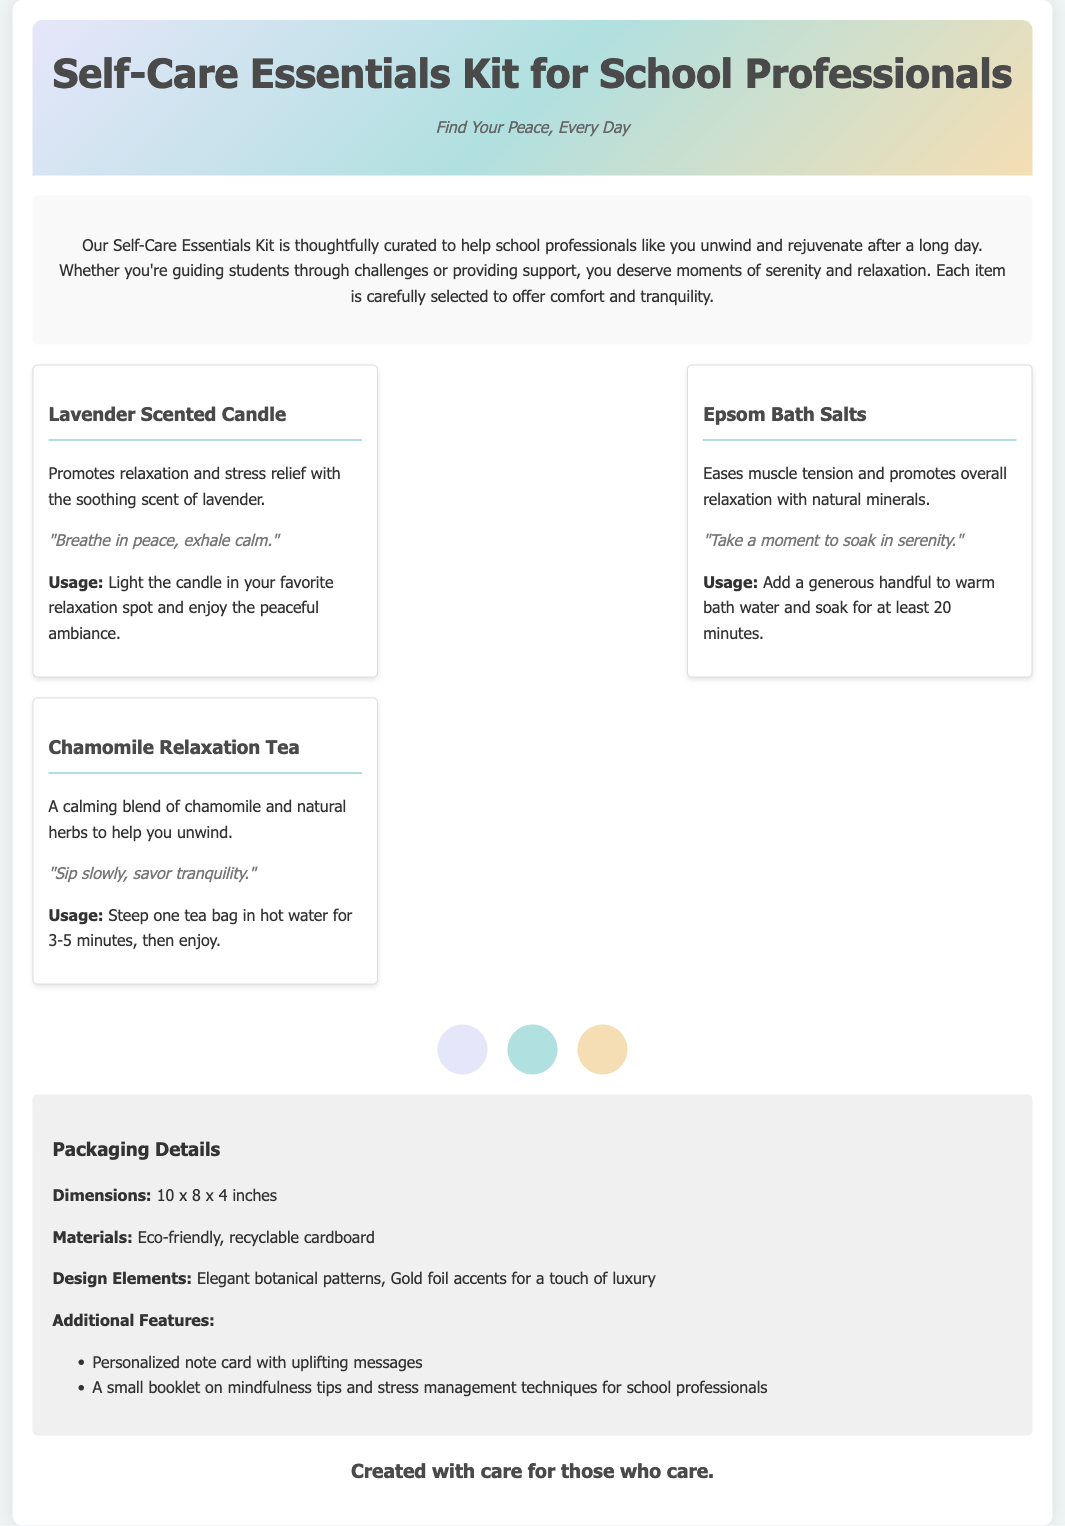what is included in the self-care essentials kit? The kit includes lavender scented candle, Epsom bath salts, and chamomile relaxation tea.
Answer: lavender scented candle, Epsom bath salts, chamomile relaxation tea what is the packaging material? The document states the packaging materials are eco-friendly and recyclable cardboard.
Answer: eco-friendly, recyclable cardboard what are the dimensions of the packaging? The dimensions of the packaging are specified within the document.
Answer: 10 x 8 x 4 inches what is the color scheme of the kit? The document mentions three colors in the color scheme: lavender, teal, and beige.
Answer: lavender, teal, beige what inspirational quote accompanies the lavender scented candle? The document provides a specific quote associated with the lavender scented candle.
Answer: "Breathe in peace, exhale calm." how many items are in the contents section? The contents section lists three different items.
Answer: 3 what is the tagline for the self-care kit? The tagline can be found at the top of the document.
Answer: Find Your Peace, Every Day what additional feature is included in the packaging? The document lists additional features that provide extra value to the product.
Answer: Personalized note card with uplifting messages what type of tea is included in the kit? The self-care kit includes a specific type of tea that is mentioned in the document.
Answer: Chamomile Relaxation Tea what is the main purpose of the self-care essentials kit? The purpose is clearly described in the opening section of the document.
Answer: Help school professionals unwind and rejuvenate 